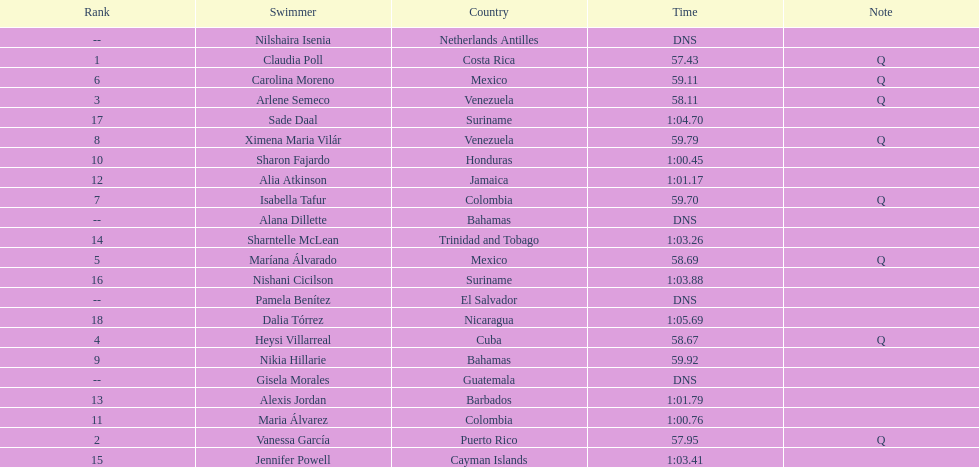Which swimmer had the longest time? Dalia Tórrez. 